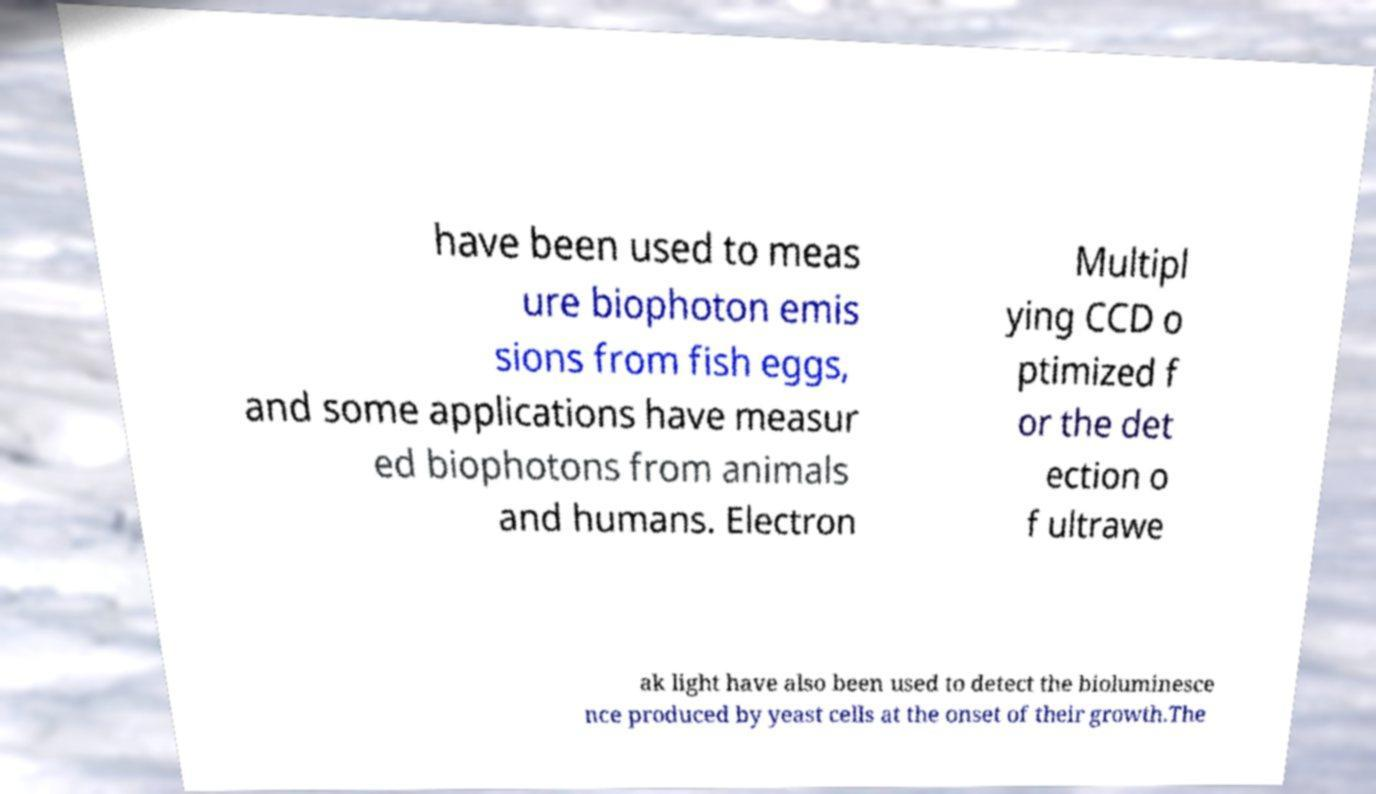I need the written content from this picture converted into text. Can you do that? have been used to meas ure biophoton emis sions from fish eggs, and some applications have measur ed biophotons from animals and humans. Electron Multipl ying CCD o ptimized f or the det ection o f ultrawe ak light have also been used to detect the bioluminesce nce produced by yeast cells at the onset of their growth.The 